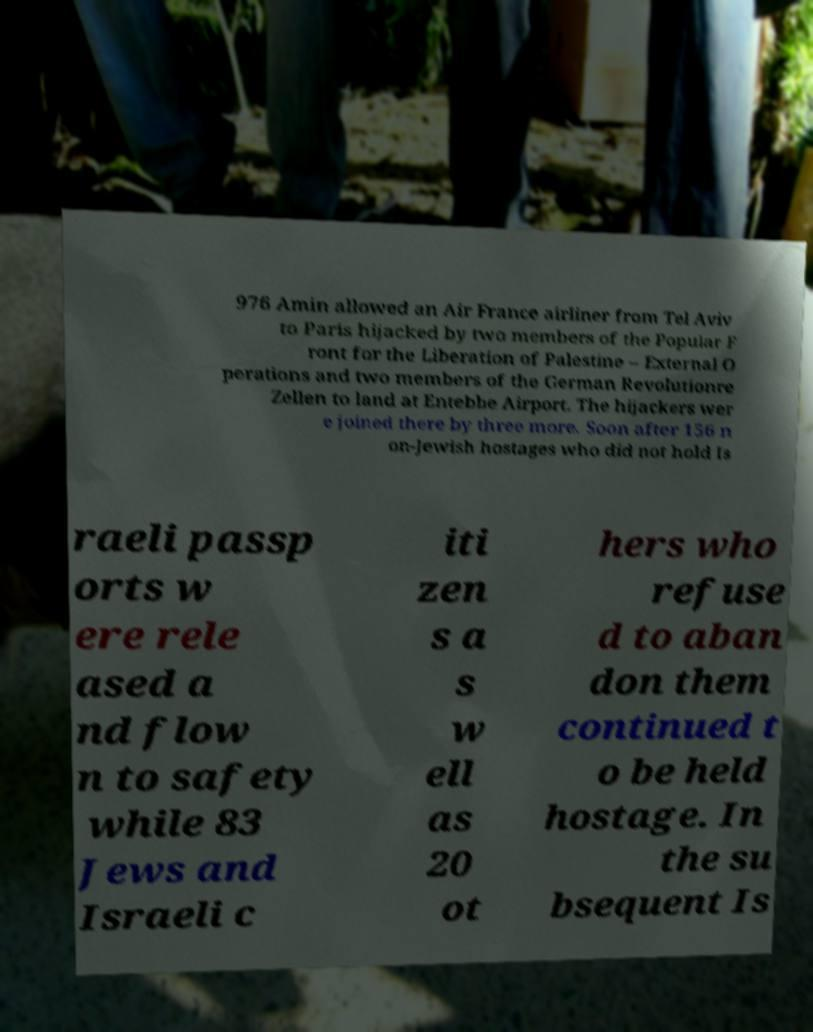What messages or text are displayed in this image? I need them in a readable, typed format. 976 Amin allowed an Air France airliner from Tel Aviv to Paris hijacked by two members of the Popular F ront for the Liberation of Palestine – External O perations and two members of the German Revolutionre Zellen to land at Entebbe Airport. The hijackers wer e joined there by three more. Soon after 156 n on-Jewish hostages who did not hold Is raeli passp orts w ere rele ased a nd flow n to safety while 83 Jews and Israeli c iti zen s a s w ell as 20 ot hers who refuse d to aban don them continued t o be held hostage. In the su bsequent Is 